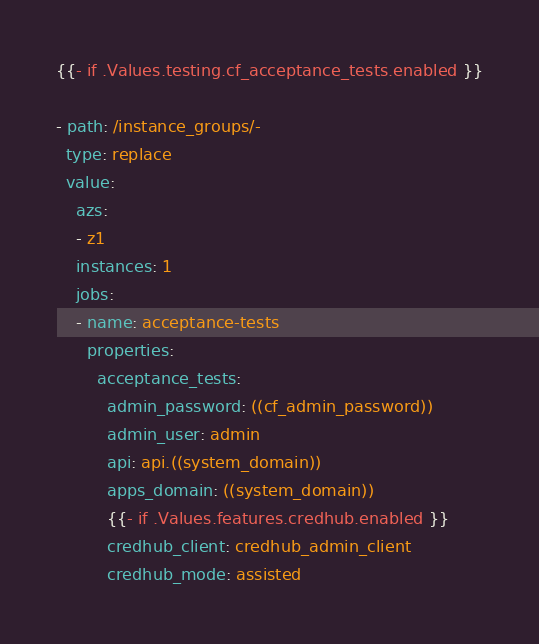Convert code to text. <code><loc_0><loc_0><loc_500><loc_500><_YAML_>{{- if .Values.testing.cf_acceptance_tests.enabled }}

- path: /instance_groups/-
  type: replace
  value:
    azs:
    - z1
    instances: 1
    jobs:
    - name: acceptance-tests
      properties:
        acceptance_tests:
          admin_password: ((cf_admin_password))
          admin_user: admin
          api: api.((system_domain))
          apps_domain: ((system_domain))
          {{- if .Values.features.credhub.enabled }}
          credhub_client: credhub_admin_client
          credhub_mode: assisted</code> 